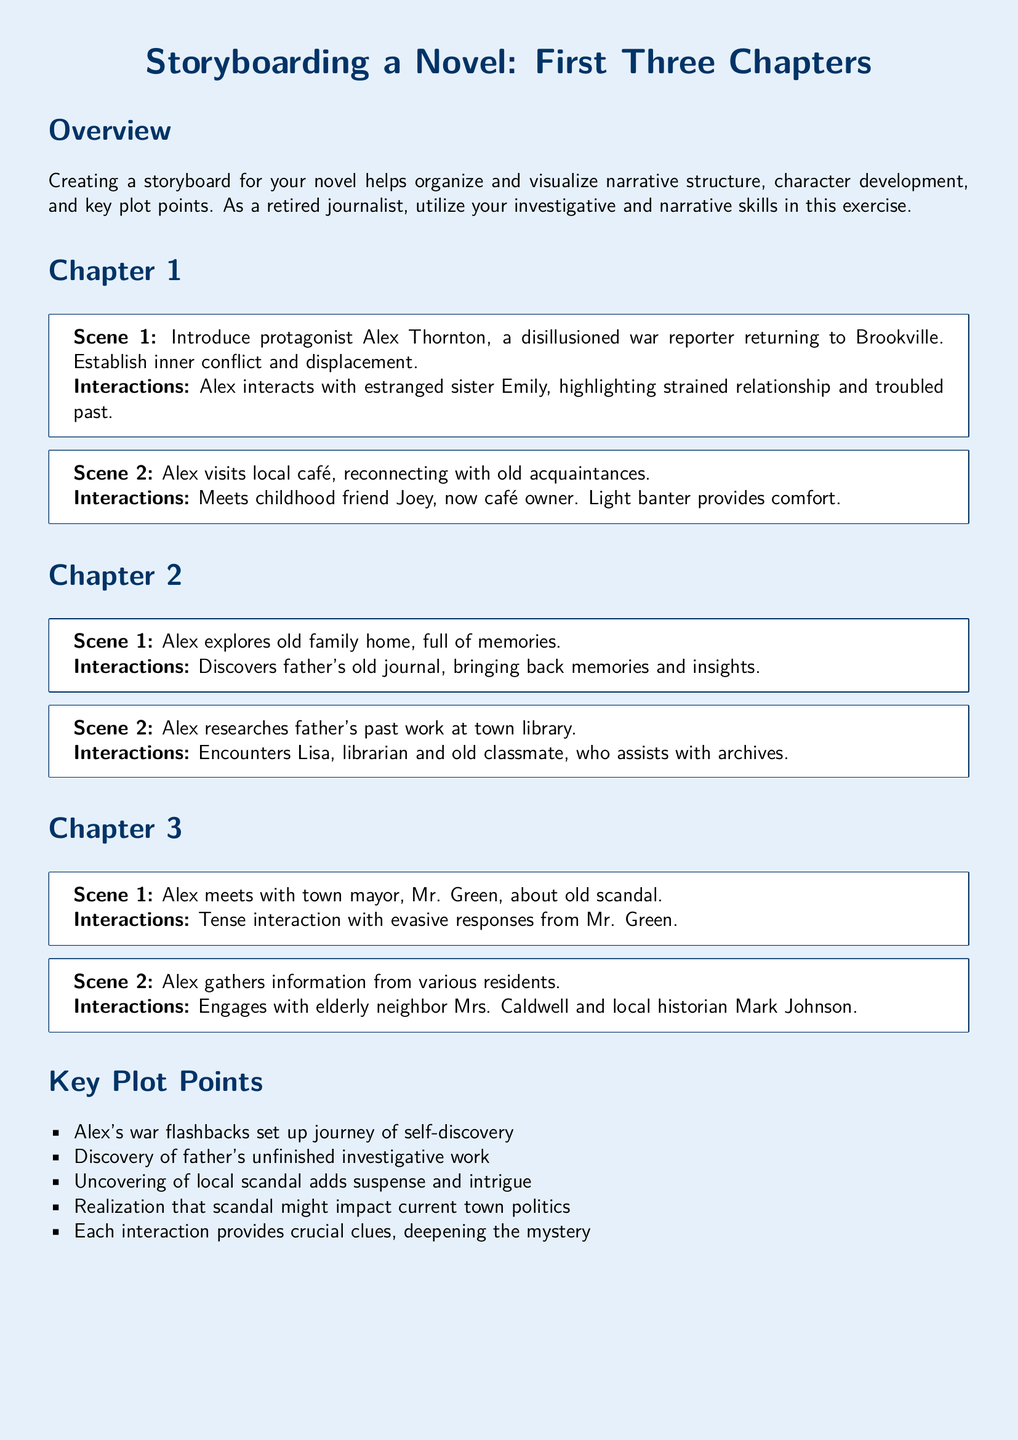What is the name of the protagonist? The protagonist is introduced in Chapter 1.
Answer: Alex Thornton Who is Alex's estranged sister? Alex interacts with her at the beginning of the story.
Answer: Emily What does Alex discover in the family home? This discovery occurs in Chapter 2.
Answer: Father's old journal Who helps Alex with research at the library? This character is introduced in Chapter 2.
Answer: Lisa What is the town mayor's name? The mayor is mentioned in Chapter 3.
Answer: Mr. Green What type of work did Alex's father do? This work is a key part of the plot.
Answer: Investigative work In which chapter does Alex visit a café? This scene occurs in Chapter 1.
Answer: Chapter 1 What is a key plot point regarding the town's politics? This reflects ongoing tension in the narrative.
Answer: Local scandal How many scenes are described in Chapter 3? The number of scenes gives an idea of content depth.
Answer: 2 